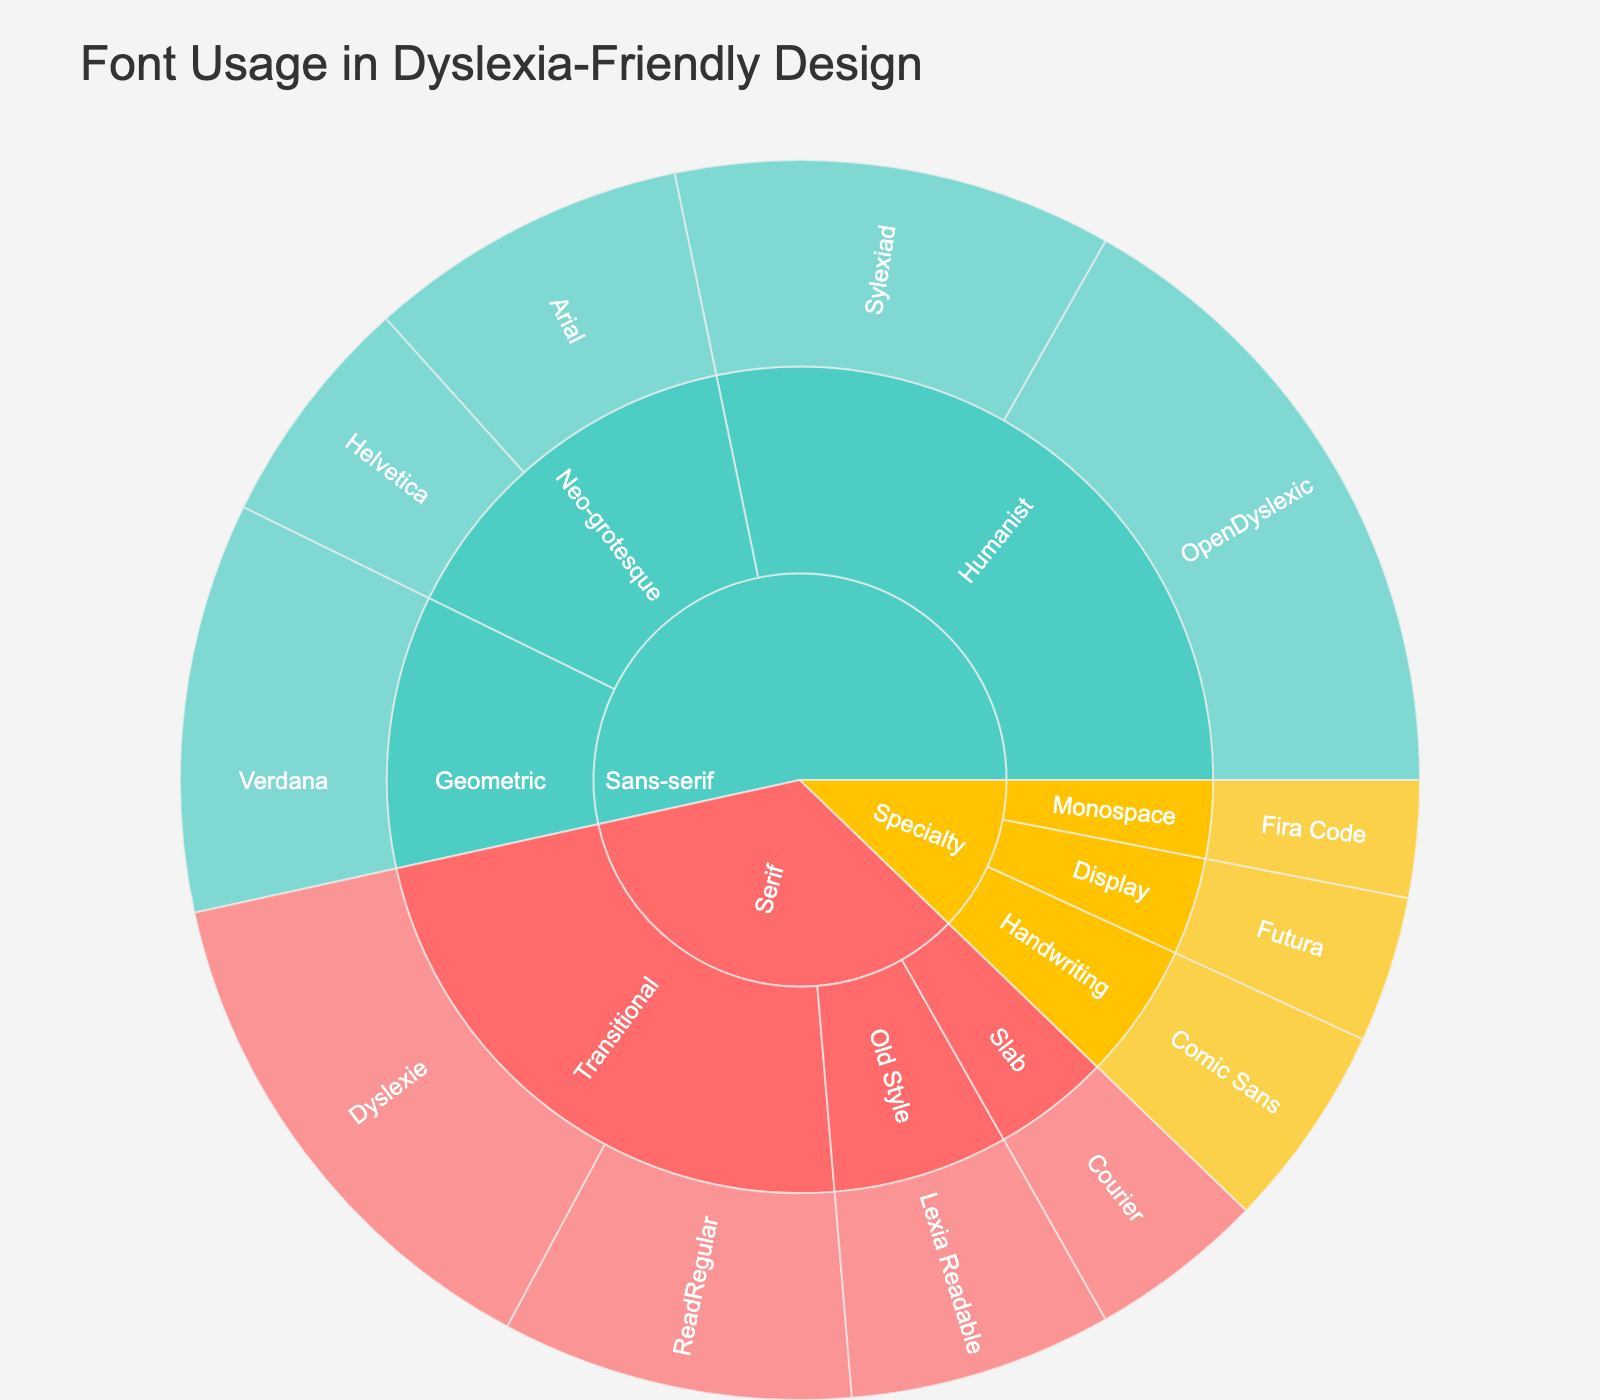Which category has the highest font usage? The sunburst plot shows three main categories: Serif, Sans-serif, and Specialty. By observing the plot, the largest segment in terms of area belongs to the Sans-serif category.
Answer: Sans-serif What's the total font usage for the Sans-serif category? To find the total font usage, you sum the usage for all fonts under the Sans-serif category: OpenDyslexic (22) + Sylexiad (15) + Verdana (14) + Arial (11) + Helvetica (8) = 70.
Answer: 70 Which specialty font has the lowest usage? The Specialty category has three subcategories: Handwriting, Display, and Monospace. Fira Code under Monospace has the smallest segment, indicating the lowest usage, which is 4.
Answer: Fira Code What is the combined usage of Transitional and Humanist fonts? Transitional fonts under Serif include Dyslexie (18) and ReadRegular (12), summing to 30. Humanist fonts under Sans-serif include OpenDyslexic (22) and Sylexiad (15), summing to 37. Combined usage is 30 + 37 = 67.
Answer: 67 Which font is unique within its own subcategory? Comic Sans under the Handwriting subcategory of the Specialty category stands alone, indicating it is unique within its subcategory.
Answer: Comic Sans Compare the usage of Serif and Specialty categories. Which one has more usage? Sum the usage of all fonts under Serif and Specialty. For Serif: Dyslexie (18) + ReadRegular (12) + Lexia Readable (9) + Courier (6) = 45. For Specialty: Comic Sans (7) + Futura (5) + Fira Code (4) = 16. Compare the sums, 45 (Serif) > 16 (Specialty).
Answer: Serif What is the average font usage for the Slab subcategory under Serif? The Slab subcategory under Serif has one font, Courier, with a usage of 6. The average usage is simply the usage of Courier.
Answer: 6 Which font in the Sans-serif category has the second-highest usage? Within the Sans-serif category, the fonts and their usages are: OpenDyslexic (22), Sylexiad (15), Verdana (14), Arial (11), and Helvetica (8). Sylexiad with 15 is the second highest.
Answer: Sylexiad How many fonts are categorized under Neo-grotesque in Sans-serif? The sunburst plot shows that the Neo-grotesque subcategory under Sans-serif includes two fonts: Arial and Helvetica.
Answer: 2 